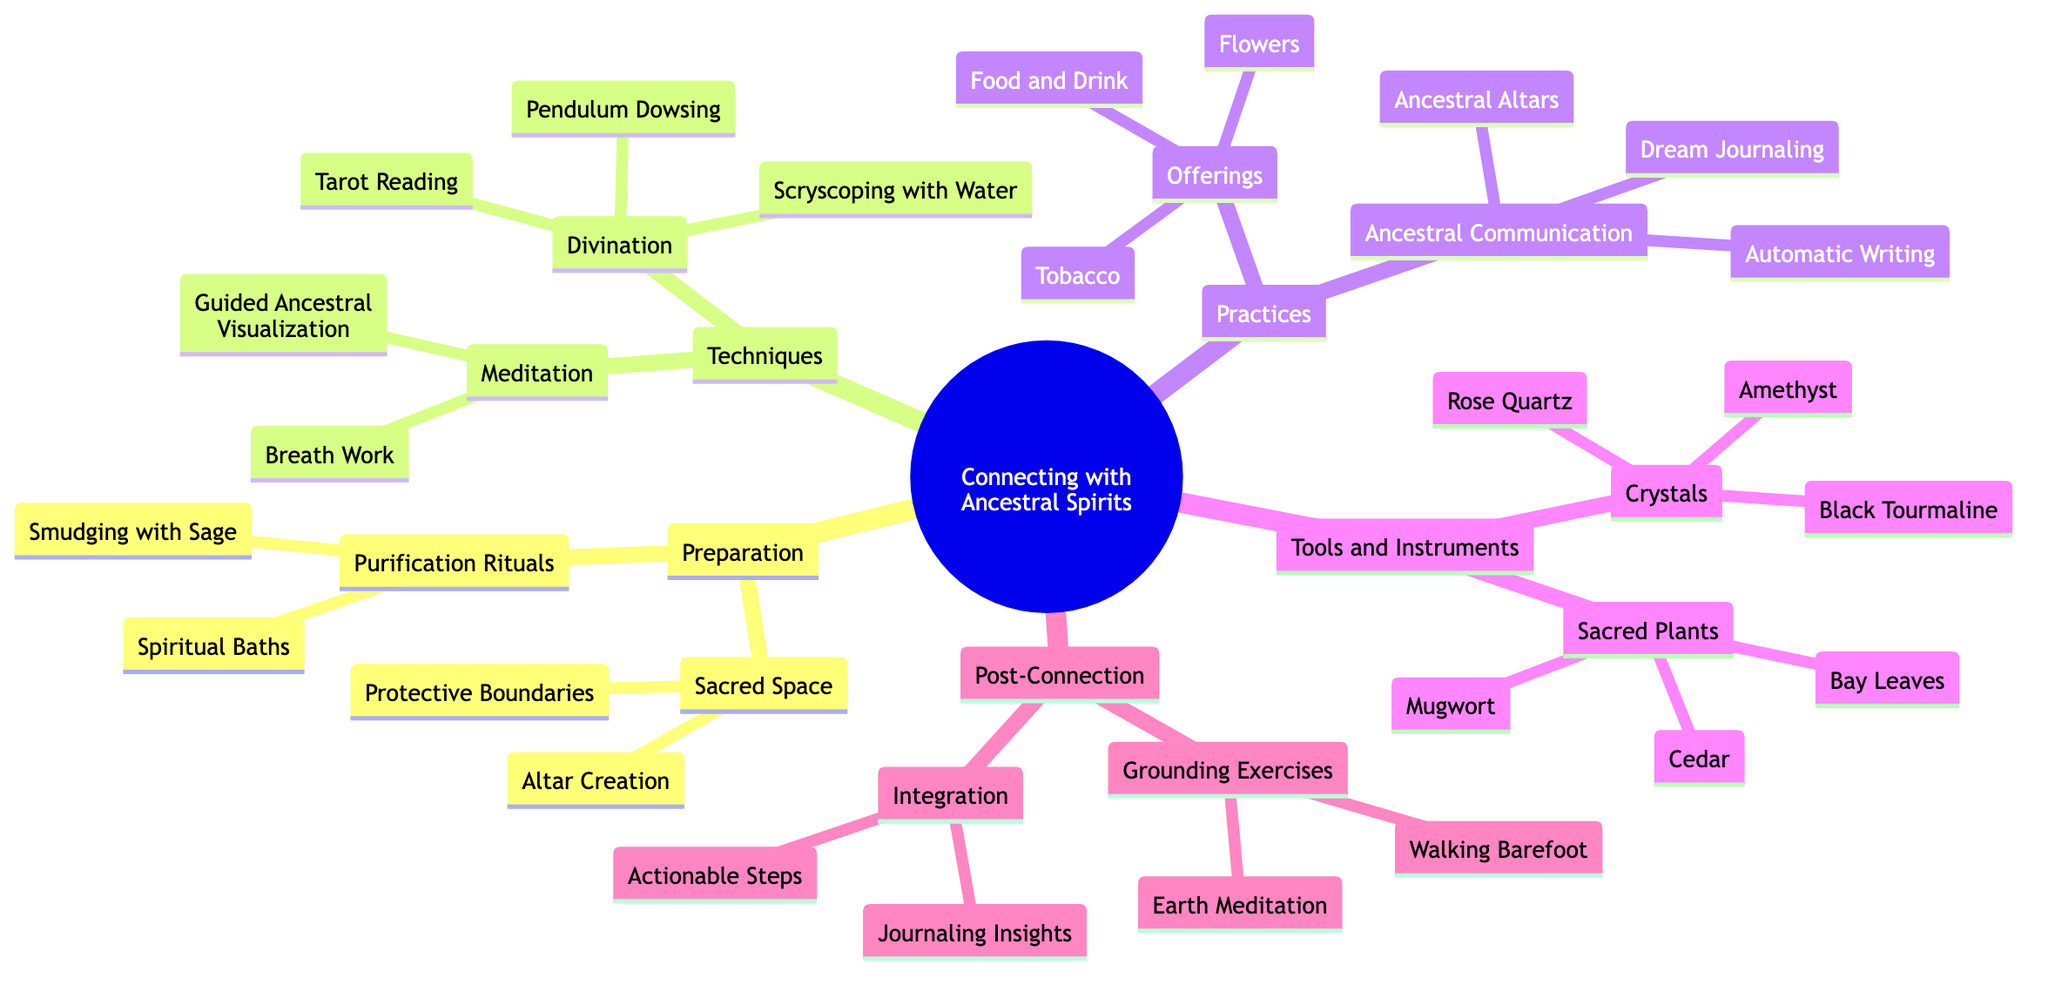What is one technique listed under Meditation? The diagram shows "Meditation" as a major branch, which has two sub-nodes: "Guided Ancestral Visualization" and "Breath Work." Thus, one technique listed is "Guided Ancestral Visualization."
Answer: Guided Ancestral Visualization How many types of offerings are mentioned? The "Offerings" node, located under the "Practices" branch, includes three sub-items: "Food and Drink," "Tobacco," and "Flowers." Therefore, there are three types of offerings mentioned.
Answer: 3 What is the first step in Preparation? The "Preparation" branch has two major sub-nodes, one of which is "Purification Rituals." The first item under this node is "Smudging with Sage." Hence, the first step in Preparation is "Smudging with Sage."
Answer: Smudging with Sage What two categories are found under Tools and Instruments? The "Tools and Instruments" branch has two main subcategories, which are "Crystals" and "Sacred Plants." Therefore, the two categories found under Tools and Instruments are "Crystals" and "Sacred Plants."
Answer: Crystals, Sacred Plants Which technique involves Tarot Reading? Within the "Techniques" branch of the diagram, under "Divination," there is a specific node for "Tarot Reading." This indicates that Tarot Reading is a technique categorized under Divination.
Answer: Divination What is the purpose of Grounding Exercises? The "Post-Connection" branch includes "Grounding Exercises," which features "Earth Meditation" and "Walking Barefoot." These activities aim to help reconnect to the earth after spiritual practices. Thus, their purpose is to facilitate grounding.
Answer: Facilitate grounding What common element is found in both Practices and Techniques? Both the "Practices" and "Techniques" branches include a component that emphasizes methods of communication and understanding with the spiritual realm. Specifically, they both involve elements designed to foster connections such as "Divination" in Techniques and "Ancestral Communication" in Practices.
Answer: Methods of communication How many purification rituals are listed? Under the "Purification Rituals" node in the "Preparation" branch, there are two items: "Smudging with Sage" and "Spiritual Baths." Thus, there are two purification rituals listed.
Answer: 2 